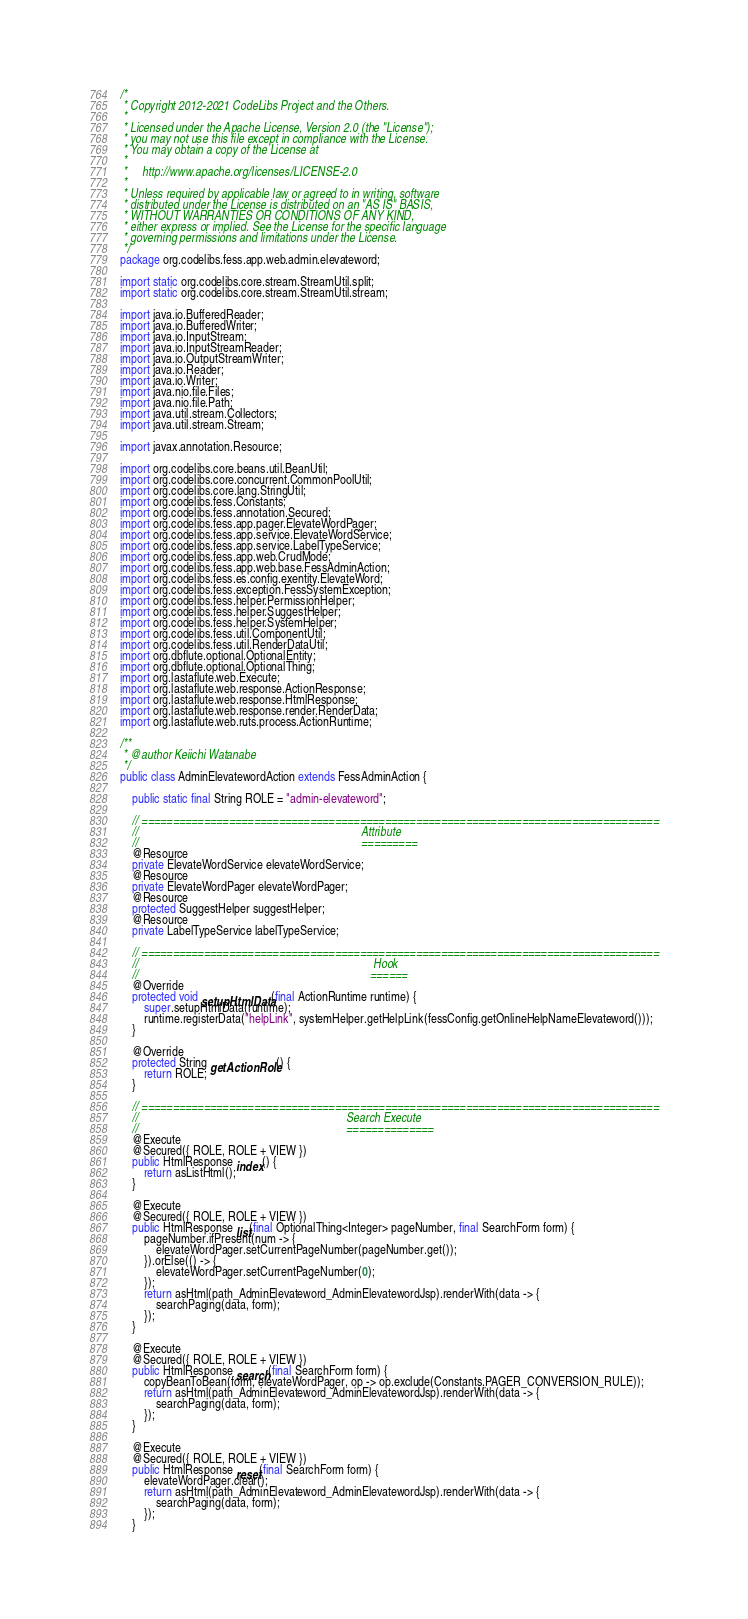<code> <loc_0><loc_0><loc_500><loc_500><_Java_>/*
 * Copyright 2012-2021 CodeLibs Project and the Others.
 *
 * Licensed under the Apache License, Version 2.0 (the "License");
 * you may not use this file except in compliance with the License.
 * You may obtain a copy of the License at
 *
 *     http://www.apache.org/licenses/LICENSE-2.0
 *
 * Unless required by applicable law or agreed to in writing, software
 * distributed under the License is distributed on an "AS IS" BASIS,
 * WITHOUT WARRANTIES OR CONDITIONS OF ANY KIND,
 * either express or implied. See the License for the specific language
 * governing permissions and limitations under the License.
 */
package org.codelibs.fess.app.web.admin.elevateword;

import static org.codelibs.core.stream.StreamUtil.split;
import static org.codelibs.core.stream.StreamUtil.stream;

import java.io.BufferedReader;
import java.io.BufferedWriter;
import java.io.InputStream;
import java.io.InputStreamReader;
import java.io.OutputStreamWriter;
import java.io.Reader;
import java.io.Writer;
import java.nio.file.Files;
import java.nio.file.Path;
import java.util.stream.Collectors;
import java.util.stream.Stream;

import javax.annotation.Resource;

import org.codelibs.core.beans.util.BeanUtil;
import org.codelibs.core.concurrent.CommonPoolUtil;
import org.codelibs.core.lang.StringUtil;
import org.codelibs.fess.Constants;
import org.codelibs.fess.annotation.Secured;
import org.codelibs.fess.app.pager.ElevateWordPager;
import org.codelibs.fess.app.service.ElevateWordService;
import org.codelibs.fess.app.service.LabelTypeService;
import org.codelibs.fess.app.web.CrudMode;
import org.codelibs.fess.app.web.base.FessAdminAction;
import org.codelibs.fess.es.config.exentity.ElevateWord;
import org.codelibs.fess.exception.FessSystemException;
import org.codelibs.fess.helper.PermissionHelper;
import org.codelibs.fess.helper.SuggestHelper;
import org.codelibs.fess.helper.SystemHelper;
import org.codelibs.fess.util.ComponentUtil;
import org.codelibs.fess.util.RenderDataUtil;
import org.dbflute.optional.OptionalEntity;
import org.dbflute.optional.OptionalThing;
import org.lastaflute.web.Execute;
import org.lastaflute.web.response.ActionResponse;
import org.lastaflute.web.response.HtmlResponse;
import org.lastaflute.web.response.render.RenderData;
import org.lastaflute.web.ruts.process.ActionRuntime;

/**
 * @author Keiichi Watanabe
 */
public class AdminElevatewordAction extends FessAdminAction {

    public static final String ROLE = "admin-elevateword";

    // ===================================================================================
    //                                                                           Attribute
    //                                                                           =========
    @Resource
    private ElevateWordService elevateWordService;
    @Resource
    private ElevateWordPager elevateWordPager;
    @Resource
    protected SuggestHelper suggestHelper;
    @Resource
    private LabelTypeService labelTypeService;

    // ===================================================================================
    //                                                                               Hook
    //                                                                              ======
    @Override
    protected void setupHtmlData(final ActionRuntime runtime) {
        super.setupHtmlData(runtime);
        runtime.registerData("helpLink", systemHelper.getHelpLink(fessConfig.getOnlineHelpNameElevateword()));
    }

    @Override
    protected String getActionRole() {
        return ROLE;
    }

    // ===================================================================================
    //                                                                      Search Execute
    //                                                                      ==============
    @Execute
    @Secured({ ROLE, ROLE + VIEW })
    public HtmlResponse index() {
        return asListHtml();
    }

    @Execute
    @Secured({ ROLE, ROLE + VIEW })
    public HtmlResponse list(final OptionalThing<Integer> pageNumber, final SearchForm form) {
        pageNumber.ifPresent(num -> {
            elevateWordPager.setCurrentPageNumber(pageNumber.get());
        }).orElse(() -> {
            elevateWordPager.setCurrentPageNumber(0);
        });
        return asHtml(path_AdminElevateword_AdminElevatewordJsp).renderWith(data -> {
            searchPaging(data, form);
        });
    }

    @Execute
    @Secured({ ROLE, ROLE + VIEW })
    public HtmlResponse search(final SearchForm form) {
        copyBeanToBean(form, elevateWordPager, op -> op.exclude(Constants.PAGER_CONVERSION_RULE));
        return asHtml(path_AdminElevateword_AdminElevatewordJsp).renderWith(data -> {
            searchPaging(data, form);
        });
    }

    @Execute
    @Secured({ ROLE, ROLE + VIEW })
    public HtmlResponse reset(final SearchForm form) {
        elevateWordPager.clear();
        return asHtml(path_AdminElevateword_AdminElevatewordJsp).renderWith(data -> {
            searchPaging(data, form);
        });
    }
</code> 